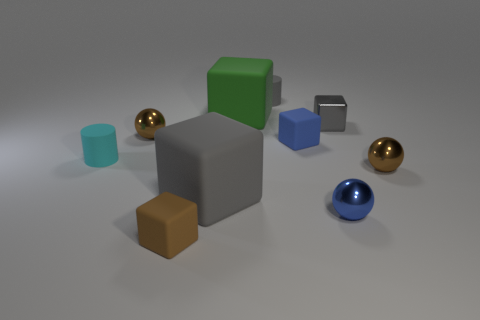Subtract all tiny gray metallic blocks. How many blocks are left? 4 Subtract all green blocks. How many blocks are left? 4 Subtract all purple cubes. Subtract all blue balls. How many cubes are left? 5 Subtract all cylinders. How many objects are left? 8 Add 8 small gray shiny objects. How many small gray shiny objects are left? 9 Add 2 large purple spheres. How many large purple spheres exist? 2 Subtract 1 blue balls. How many objects are left? 9 Subtract all small cylinders. Subtract all small rubber cylinders. How many objects are left? 6 